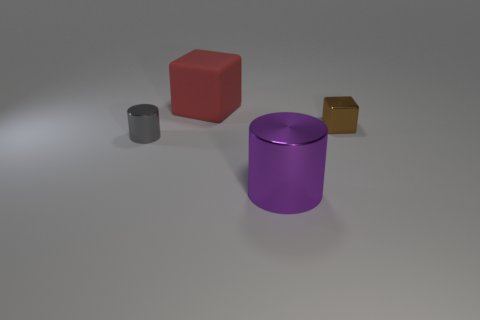Add 3 tiny brown metallic cubes. How many objects exist? 7 Add 4 purple shiny cylinders. How many purple shiny cylinders exist? 5 Subtract 0 gray balls. How many objects are left? 4 Subtract all yellow cubes. Subtract all yellow spheres. How many cubes are left? 2 Subtract all yellow matte spheres. Subtract all big red rubber cubes. How many objects are left? 3 Add 2 matte objects. How many matte objects are left? 3 